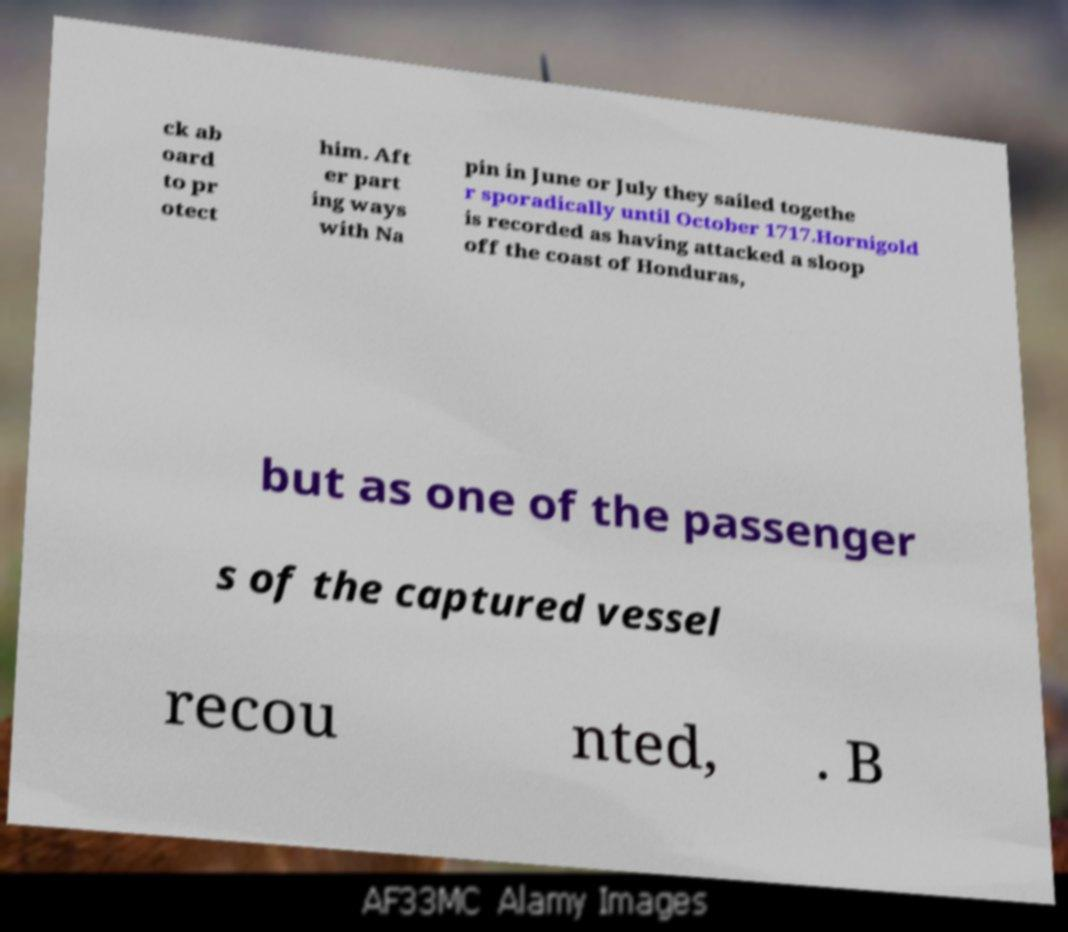Can you read and provide the text displayed in the image?This photo seems to have some interesting text. Can you extract and type it out for me? ck ab oard to pr otect him. Aft er part ing ways with Na pin in June or July they sailed togethe r sporadically until October 1717.Hornigold is recorded as having attacked a sloop off the coast of Honduras, but as one of the passenger s of the captured vessel recou nted, . B 